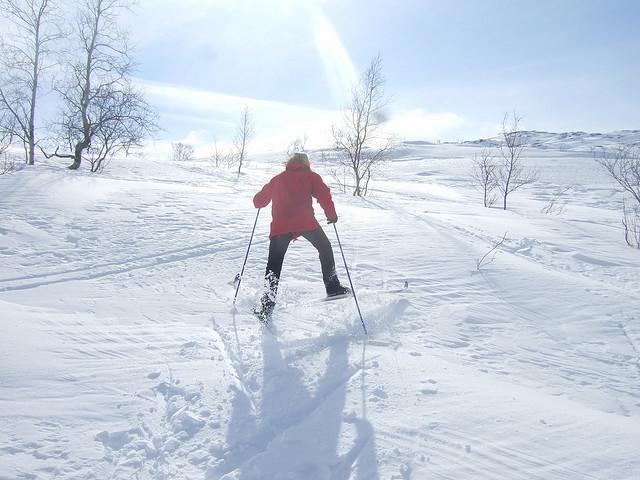What color is the person's jacket?
Answer briefly. Red. What is behind these people?
Keep it brief. Snow. What is the color of the sky?
Be succinct. Blue. Is it a snowy day?
Quick response, please. Yes. What color are the trees?
Give a very brief answer. Brown. Is there a parking lot?
Write a very short answer. No. Does he have the appropriate gear with him?
Short answer required. Yes. Should this person have ski poles?
Write a very short answer. Yes. Which direction is the man traveling?
Concise answer only. North. 